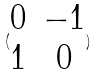<formula> <loc_0><loc_0><loc_500><loc_500>( \begin{matrix} 0 & - 1 \\ 1 & 0 \end{matrix} )</formula> 